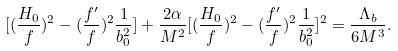Convert formula to latex. <formula><loc_0><loc_0><loc_500><loc_500>[ ( \frac { H _ { 0 } } { f } ) ^ { 2 } - ( \frac { f ^ { \prime } } { f } ) ^ { 2 } \frac { 1 } { b _ { 0 } ^ { 2 } } ] + \frac { 2 \alpha } { M ^ { 2 } } [ ( \frac { H _ { 0 } } { f } ) ^ { 2 } - ( \frac { f ^ { \prime } } { f } ) ^ { 2 } \frac { 1 } { b _ { 0 } ^ { 2 } } ] ^ { 2 } = \frac { \Lambda _ { b } } { 6 M ^ { 3 } } .</formula> 